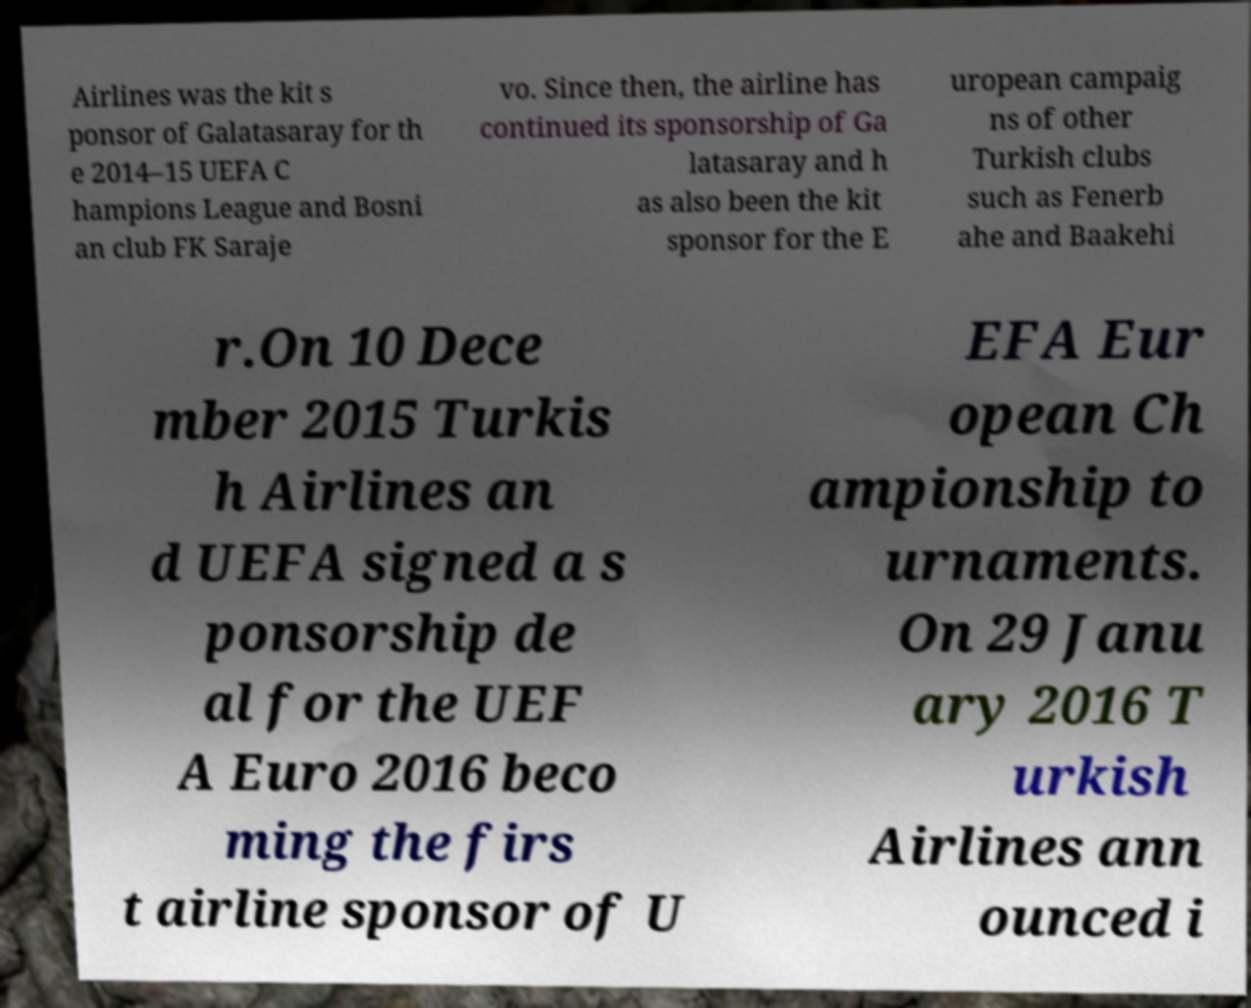Please read and relay the text visible in this image. What does it say? Airlines was the kit s ponsor of Galatasaray for th e 2014–15 UEFA C hampions League and Bosni an club FK Saraje vo. Since then, the airline has continued its sponsorship of Ga latasaray and h as also been the kit sponsor for the E uropean campaig ns of other Turkish clubs such as Fenerb ahe and Baakehi r.On 10 Dece mber 2015 Turkis h Airlines an d UEFA signed a s ponsorship de al for the UEF A Euro 2016 beco ming the firs t airline sponsor of U EFA Eur opean Ch ampionship to urnaments. On 29 Janu ary 2016 T urkish Airlines ann ounced i 